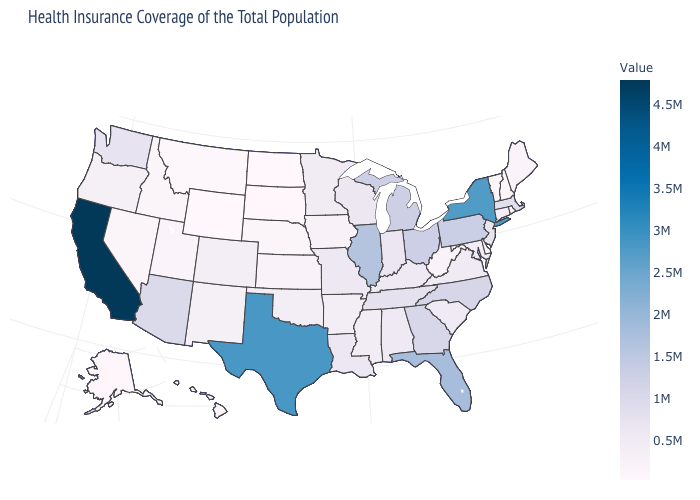Is the legend a continuous bar?
Be succinct. Yes. Does California have the highest value in the USA?
Be succinct. Yes. Among the states that border Pennsylvania , does New York have the highest value?
Keep it brief. Yes. Which states have the lowest value in the USA?
Quick response, please. North Dakota. Which states have the lowest value in the USA?
Quick response, please. North Dakota. Among the states that border Michigan , does Ohio have the highest value?
Quick response, please. Yes. 